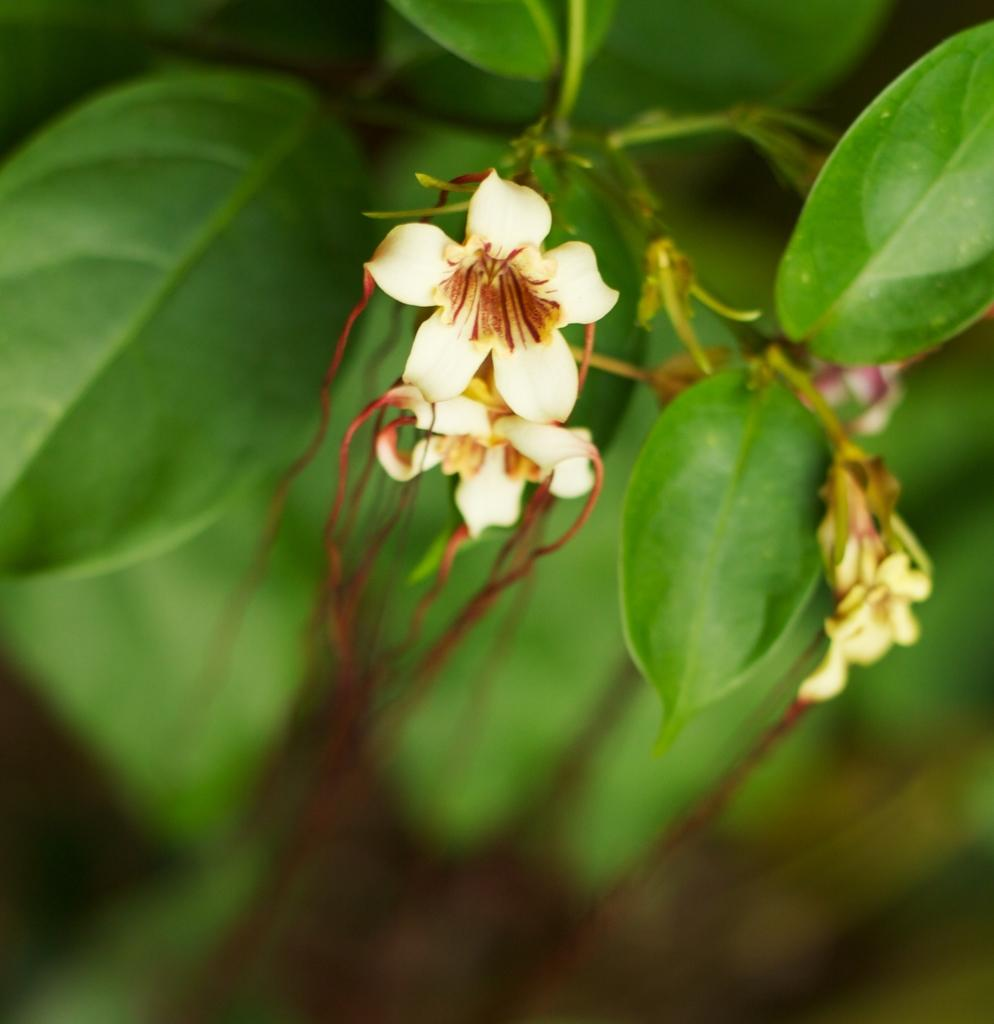What type of flora is present in the image? There are flowers in the image. What color are the flowers? The flowers are white in color. What else can be seen in the background of the image? There are leaves visible in the background of the image. How would you describe the overall clarity of the image? The image appears to be slightly blurred. Can you see any agreements being signed in the image? There is no reference to any agreements or signing in the image; it features white flowers and leaves in the background. 